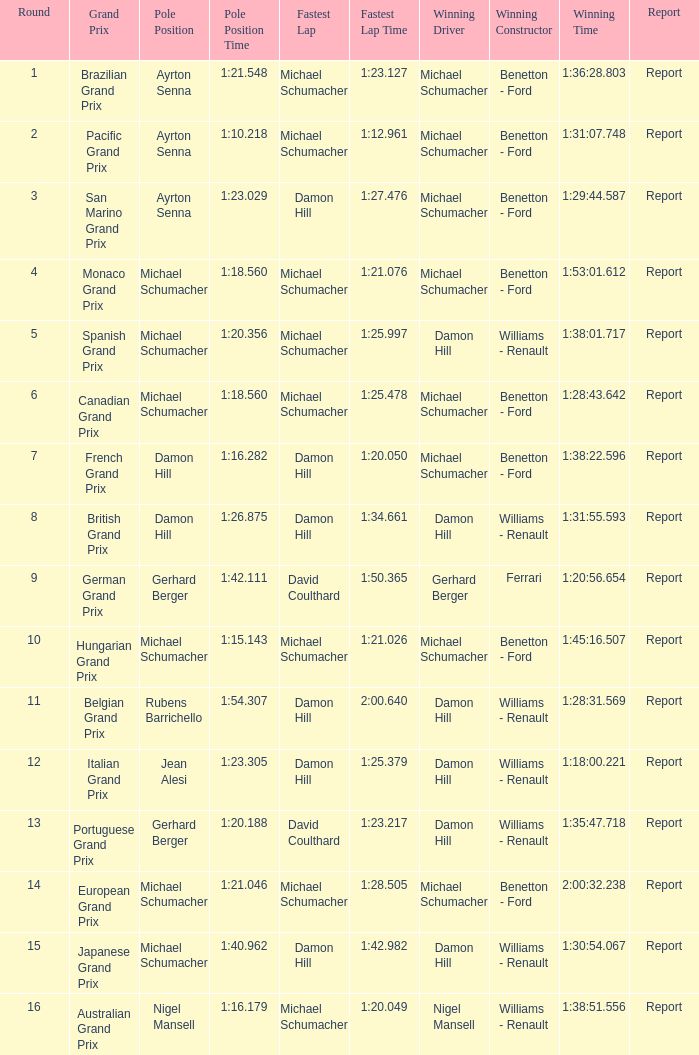At the earliest stage, when did michael schumacher hold the pole position and emerge as the winning driver? 4.0. 